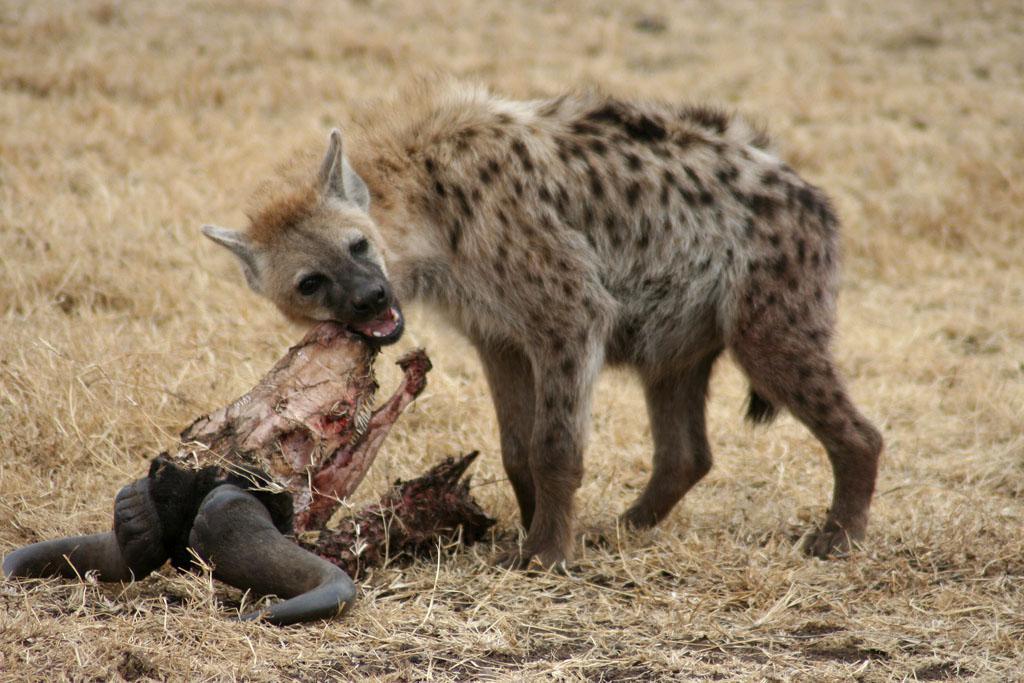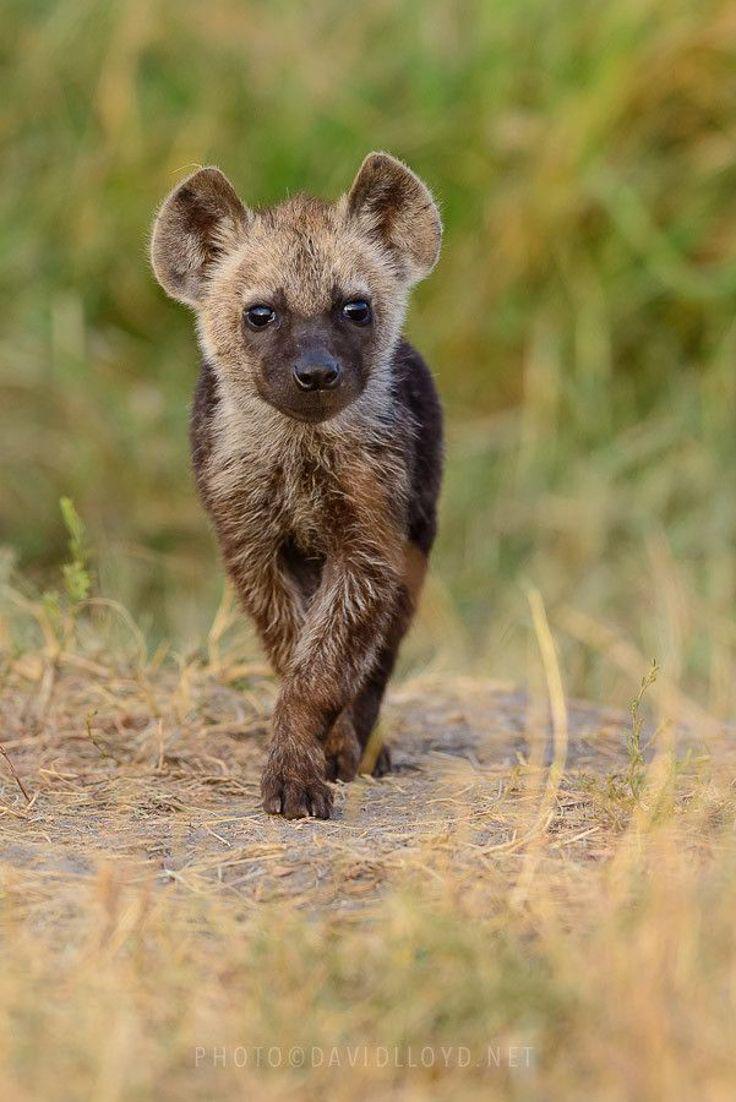The first image is the image on the left, the second image is the image on the right. Given the left and right images, does the statement "One of the images contains a hyena eating a dead animal." hold true? Answer yes or no. Yes. 